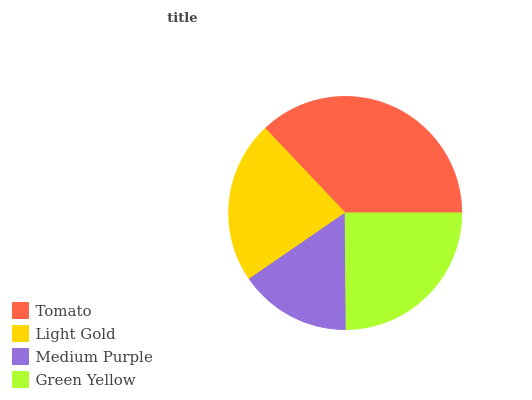Is Medium Purple the minimum?
Answer yes or no. Yes. Is Tomato the maximum?
Answer yes or no. Yes. Is Light Gold the minimum?
Answer yes or no. No. Is Light Gold the maximum?
Answer yes or no. No. Is Tomato greater than Light Gold?
Answer yes or no. Yes. Is Light Gold less than Tomato?
Answer yes or no. Yes. Is Light Gold greater than Tomato?
Answer yes or no. No. Is Tomato less than Light Gold?
Answer yes or no. No. Is Green Yellow the high median?
Answer yes or no. Yes. Is Light Gold the low median?
Answer yes or no. Yes. Is Tomato the high median?
Answer yes or no. No. Is Tomato the low median?
Answer yes or no. No. 